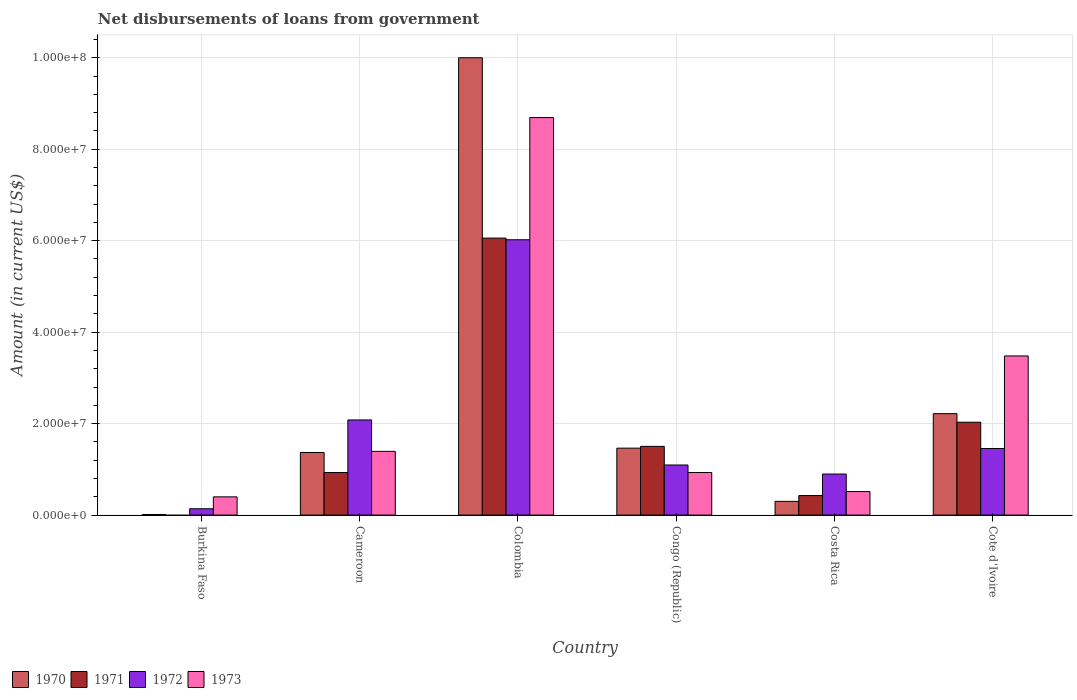How many different coloured bars are there?
Offer a terse response. 4. Are the number of bars per tick equal to the number of legend labels?
Provide a short and direct response. No. How many bars are there on the 6th tick from the right?
Offer a terse response. 3. What is the label of the 3rd group of bars from the left?
Keep it short and to the point. Colombia. What is the amount of loan disbursed from government in 1972 in Colombia?
Give a very brief answer. 6.02e+07. Across all countries, what is the maximum amount of loan disbursed from government in 1971?
Offer a terse response. 6.06e+07. What is the total amount of loan disbursed from government in 1970 in the graph?
Your response must be concise. 1.54e+08. What is the difference between the amount of loan disbursed from government in 1970 in Congo (Republic) and that in Costa Rica?
Offer a very short reply. 1.16e+07. What is the difference between the amount of loan disbursed from government in 1972 in Colombia and the amount of loan disbursed from government in 1970 in Costa Rica?
Offer a terse response. 5.72e+07. What is the average amount of loan disbursed from government in 1971 per country?
Your response must be concise. 1.82e+07. What is the difference between the amount of loan disbursed from government of/in 1972 and amount of loan disbursed from government of/in 1973 in Cameroon?
Give a very brief answer. 6.87e+06. In how many countries, is the amount of loan disbursed from government in 1971 greater than 24000000 US$?
Your response must be concise. 1. What is the ratio of the amount of loan disbursed from government in 1970 in Cameroon to that in Cote d'Ivoire?
Keep it short and to the point. 0.62. Is the amount of loan disbursed from government in 1970 in Cameroon less than that in Colombia?
Give a very brief answer. Yes. Is the difference between the amount of loan disbursed from government in 1972 in Burkina Faso and Colombia greater than the difference between the amount of loan disbursed from government in 1973 in Burkina Faso and Colombia?
Ensure brevity in your answer.  Yes. What is the difference between the highest and the second highest amount of loan disbursed from government in 1970?
Your answer should be very brief. 8.54e+07. What is the difference between the highest and the lowest amount of loan disbursed from government in 1973?
Your answer should be very brief. 8.29e+07. How many bars are there?
Keep it short and to the point. 23. Are all the bars in the graph horizontal?
Your answer should be compact. No. How many countries are there in the graph?
Your answer should be compact. 6. What is the difference between two consecutive major ticks on the Y-axis?
Your answer should be very brief. 2.00e+07. Does the graph contain grids?
Offer a terse response. Yes. How many legend labels are there?
Ensure brevity in your answer.  4. How are the legend labels stacked?
Provide a short and direct response. Horizontal. What is the title of the graph?
Make the answer very short. Net disbursements of loans from government. What is the Amount (in current US$) of 1970 in Burkina Faso?
Provide a succinct answer. 1.29e+05. What is the Amount (in current US$) in 1972 in Burkina Faso?
Provide a succinct answer. 1.38e+06. What is the Amount (in current US$) in 1973 in Burkina Faso?
Provide a succinct answer. 3.98e+06. What is the Amount (in current US$) in 1970 in Cameroon?
Your answer should be very brief. 1.37e+07. What is the Amount (in current US$) in 1971 in Cameroon?
Keep it short and to the point. 9.30e+06. What is the Amount (in current US$) of 1972 in Cameroon?
Provide a short and direct response. 2.08e+07. What is the Amount (in current US$) of 1973 in Cameroon?
Make the answer very short. 1.39e+07. What is the Amount (in current US$) of 1970 in Colombia?
Your answer should be compact. 1.00e+08. What is the Amount (in current US$) of 1971 in Colombia?
Your response must be concise. 6.06e+07. What is the Amount (in current US$) of 1972 in Colombia?
Provide a short and direct response. 6.02e+07. What is the Amount (in current US$) in 1973 in Colombia?
Offer a terse response. 8.69e+07. What is the Amount (in current US$) in 1970 in Congo (Republic)?
Make the answer very short. 1.46e+07. What is the Amount (in current US$) in 1971 in Congo (Republic)?
Give a very brief answer. 1.50e+07. What is the Amount (in current US$) in 1972 in Congo (Republic)?
Offer a terse response. 1.10e+07. What is the Amount (in current US$) in 1973 in Congo (Republic)?
Your answer should be very brief. 9.30e+06. What is the Amount (in current US$) in 1970 in Costa Rica?
Your answer should be compact. 3.00e+06. What is the Amount (in current US$) in 1971 in Costa Rica?
Your response must be concise. 4.27e+06. What is the Amount (in current US$) in 1972 in Costa Rica?
Provide a short and direct response. 8.97e+06. What is the Amount (in current US$) of 1973 in Costa Rica?
Give a very brief answer. 5.14e+06. What is the Amount (in current US$) in 1970 in Cote d'Ivoire?
Make the answer very short. 2.22e+07. What is the Amount (in current US$) of 1971 in Cote d'Ivoire?
Offer a very short reply. 2.03e+07. What is the Amount (in current US$) of 1972 in Cote d'Ivoire?
Provide a succinct answer. 1.45e+07. What is the Amount (in current US$) in 1973 in Cote d'Ivoire?
Your answer should be very brief. 3.48e+07. Across all countries, what is the maximum Amount (in current US$) of 1970?
Your answer should be compact. 1.00e+08. Across all countries, what is the maximum Amount (in current US$) in 1971?
Your answer should be very brief. 6.06e+07. Across all countries, what is the maximum Amount (in current US$) in 1972?
Offer a very short reply. 6.02e+07. Across all countries, what is the maximum Amount (in current US$) of 1973?
Ensure brevity in your answer.  8.69e+07. Across all countries, what is the minimum Amount (in current US$) of 1970?
Make the answer very short. 1.29e+05. Across all countries, what is the minimum Amount (in current US$) of 1972?
Offer a very short reply. 1.38e+06. Across all countries, what is the minimum Amount (in current US$) in 1973?
Ensure brevity in your answer.  3.98e+06. What is the total Amount (in current US$) of 1970 in the graph?
Provide a succinct answer. 1.54e+08. What is the total Amount (in current US$) of 1971 in the graph?
Provide a succinct answer. 1.09e+08. What is the total Amount (in current US$) of 1972 in the graph?
Offer a terse response. 1.17e+08. What is the total Amount (in current US$) in 1973 in the graph?
Your answer should be compact. 1.54e+08. What is the difference between the Amount (in current US$) in 1970 in Burkina Faso and that in Cameroon?
Provide a succinct answer. -1.36e+07. What is the difference between the Amount (in current US$) in 1972 in Burkina Faso and that in Cameroon?
Keep it short and to the point. -1.94e+07. What is the difference between the Amount (in current US$) in 1973 in Burkina Faso and that in Cameroon?
Your response must be concise. -9.94e+06. What is the difference between the Amount (in current US$) of 1970 in Burkina Faso and that in Colombia?
Make the answer very short. -9.99e+07. What is the difference between the Amount (in current US$) in 1972 in Burkina Faso and that in Colombia?
Keep it short and to the point. -5.88e+07. What is the difference between the Amount (in current US$) in 1973 in Burkina Faso and that in Colombia?
Give a very brief answer. -8.29e+07. What is the difference between the Amount (in current US$) of 1970 in Burkina Faso and that in Congo (Republic)?
Provide a short and direct response. -1.45e+07. What is the difference between the Amount (in current US$) of 1972 in Burkina Faso and that in Congo (Republic)?
Your response must be concise. -9.57e+06. What is the difference between the Amount (in current US$) in 1973 in Burkina Faso and that in Congo (Republic)?
Offer a terse response. -5.32e+06. What is the difference between the Amount (in current US$) of 1970 in Burkina Faso and that in Costa Rica?
Make the answer very short. -2.87e+06. What is the difference between the Amount (in current US$) of 1972 in Burkina Faso and that in Costa Rica?
Give a very brief answer. -7.59e+06. What is the difference between the Amount (in current US$) of 1973 in Burkina Faso and that in Costa Rica?
Make the answer very short. -1.15e+06. What is the difference between the Amount (in current US$) in 1970 in Burkina Faso and that in Cote d'Ivoire?
Your answer should be compact. -2.20e+07. What is the difference between the Amount (in current US$) of 1972 in Burkina Faso and that in Cote d'Ivoire?
Your answer should be very brief. -1.32e+07. What is the difference between the Amount (in current US$) of 1973 in Burkina Faso and that in Cote d'Ivoire?
Give a very brief answer. -3.08e+07. What is the difference between the Amount (in current US$) in 1970 in Cameroon and that in Colombia?
Provide a short and direct response. -8.63e+07. What is the difference between the Amount (in current US$) of 1971 in Cameroon and that in Colombia?
Provide a succinct answer. -5.13e+07. What is the difference between the Amount (in current US$) of 1972 in Cameroon and that in Colombia?
Your answer should be very brief. -3.94e+07. What is the difference between the Amount (in current US$) of 1973 in Cameroon and that in Colombia?
Provide a succinct answer. -7.30e+07. What is the difference between the Amount (in current US$) in 1970 in Cameroon and that in Congo (Republic)?
Your response must be concise. -9.51e+05. What is the difference between the Amount (in current US$) of 1971 in Cameroon and that in Congo (Republic)?
Give a very brief answer. -5.72e+06. What is the difference between the Amount (in current US$) in 1972 in Cameroon and that in Congo (Republic)?
Keep it short and to the point. 9.85e+06. What is the difference between the Amount (in current US$) in 1973 in Cameroon and that in Congo (Republic)?
Ensure brevity in your answer.  4.63e+06. What is the difference between the Amount (in current US$) of 1970 in Cameroon and that in Costa Rica?
Offer a very short reply. 1.07e+07. What is the difference between the Amount (in current US$) in 1971 in Cameroon and that in Costa Rica?
Make the answer very short. 5.03e+06. What is the difference between the Amount (in current US$) of 1972 in Cameroon and that in Costa Rica?
Provide a short and direct response. 1.18e+07. What is the difference between the Amount (in current US$) in 1973 in Cameroon and that in Costa Rica?
Your answer should be very brief. 8.79e+06. What is the difference between the Amount (in current US$) of 1970 in Cameroon and that in Cote d'Ivoire?
Your response must be concise. -8.50e+06. What is the difference between the Amount (in current US$) of 1971 in Cameroon and that in Cote d'Ivoire?
Provide a short and direct response. -1.10e+07. What is the difference between the Amount (in current US$) in 1972 in Cameroon and that in Cote d'Ivoire?
Offer a terse response. 6.25e+06. What is the difference between the Amount (in current US$) of 1973 in Cameroon and that in Cote d'Ivoire?
Keep it short and to the point. -2.09e+07. What is the difference between the Amount (in current US$) in 1970 in Colombia and that in Congo (Republic)?
Ensure brevity in your answer.  8.54e+07. What is the difference between the Amount (in current US$) of 1971 in Colombia and that in Congo (Republic)?
Give a very brief answer. 4.55e+07. What is the difference between the Amount (in current US$) in 1972 in Colombia and that in Congo (Republic)?
Your response must be concise. 4.92e+07. What is the difference between the Amount (in current US$) of 1973 in Colombia and that in Congo (Republic)?
Provide a short and direct response. 7.76e+07. What is the difference between the Amount (in current US$) in 1970 in Colombia and that in Costa Rica?
Ensure brevity in your answer.  9.70e+07. What is the difference between the Amount (in current US$) in 1971 in Colombia and that in Costa Rica?
Your answer should be compact. 5.63e+07. What is the difference between the Amount (in current US$) in 1972 in Colombia and that in Costa Rica?
Ensure brevity in your answer.  5.12e+07. What is the difference between the Amount (in current US$) of 1973 in Colombia and that in Costa Rica?
Your response must be concise. 8.18e+07. What is the difference between the Amount (in current US$) in 1970 in Colombia and that in Cote d'Ivoire?
Make the answer very short. 7.78e+07. What is the difference between the Amount (in current US$) in 1971 in Colombia and that in Cote d'Ivoire?
Provide a succinct answer. 4.03e+07. What is the difference between the Amount (in current US$) in 1972 in Colombia and that in Cote d'Ivoire?
Give a very brief answer. 4.56e+07. What is the difference between the Amount (in current US$) in 1973 in Colombia and that in Cote d'Ivoire?
Your response must be concise. 5.21e+07. What is the difference between the Amount (in current US$) of 1970 in Congo (Republic) and that in Costa Rica?
Provide a succinct answer. 1.16e+07. What is the difference between the Amount (in current US$) of 1971 in Congo (Republic) and that in Costa Rica?
Offer a terse response. 1.08e+07. What is the difference between the Amount (in current US$) of 1972 in Congo (Republic) and that in Costa Rica?
Offer a terse response. 1.98e+06. What is the difference between the Amount (in current US$) in 1973 in Congo (Republic) and that in Costa Rica?
Your answer should be compact. 4.16e+06. What is the difference between the Amount (in current US$) in 1970 in Congo (Republic) and that in Cote d'Ivoire?
Your response must be concise. -7.54e+06. What is the difference between the Amount (in current US$) in 1971 in Congo (Republic) and that in Cote d'Ivoire?
Give a very brief answer. -5.28e+06. What is the difference between the Amount (in current US$) of 1972 in Congo (Republic) and that in Cote d'Ivoire?
Offer a very short reply. -3.60e+06. What is the difference between the Amount (in current US$) of 1973 in Congo (Republic) and that in Cote d'Ivoire?
Provide a short and direct response. -2.55e+07. What is the difference between the Amount (in current US$) in 1970 in Costa Rica and that in Cote d'Ivoire?
Give a very brief answer. -1.92e+07. What is the difference between the Amount (in current US$) in 1971 in Costa Rica and that in Cote d'Ivoire?
Your answer should be compact. -1.60e+07. What is the difference between the Amount (in current US$) in 1972 in Costa Rica and that in Cote d'Ivoire?
Your answer should be compact. -5.58e+06. What is the difference between the Amount (in current US$) of 1973 in Costa Rica and that in Cote d'Ivoire?
Ensure brevity in your answer.  -2.97e+07. What is the difference between the Amount (in current US$) in 1970 in Burkina Faso and the Amount (in current US$) in 1971 in Cameroon?
Your answer should be compact. -9.17e+06. What is the difference between the Amount (in current US$) in 1970 in Burkina Faso and the Amount (in current US$) in 1972 in Cameroon?
Keep it short and to the point. -2.07e+07. What is the difference between the Amount (in current US$) of 1970 in Burkina Faso and the Amount (in current US$) of 1973 in Cameroon?
Keep it short and to the point. -1.38e+07. What is the difference between the Amount (in current US$) in 1972 in Burkina Faso and the Amount (in current US$) in 1973 in Cameroon?
Provide a succinct answer. -1.25e+07. What is the difference between the Amount (in current US$) in 1970 in Burkina Faso and the Amount (in current US$) in 1971 in Colombia?
Offer a very short reply. -6.04e+07. What is the difference between the Amount (in current US$) in 1970 in Burkina Faso and the Amount (in current US$) in 1972 in Colombia?
Provide a short and direct response. -6.01e+07. What is the difference between the Amount (in current US$) of 1970 in Burkina Faso and the Amount (in current US$) of 1973 in Colombia?
Give a very brief answer. -8.68e+07. What is the difference between the Amount (in current US$) in 1972 in Burkina Faso and the Amount (in current US$) in 1973 in Colombia?
Your answer should be compact. -8.55e+07. What is the difference between the Amount (in current US$) in 1970 in Burkina Faso and the Amount (in current US$) in 1971 in Congo (Republic)?
Make the answer very short. -1.49e+07. What is the difference between the Amount (in current US$) of 1970 in Burkina Faso and the Amount (in current US$) of 1972 in Congo (Republic)?
Provide a short and direct response. -1.08e+07. What is the difference between the Amount (in current US$) in 1970 in Burkina Faso and the Amount (in current US$) in 1973 in Congo (Republic)?
Make the answer very short. -9.17e+06. What is the difference between the Amount (in current US$) in 1972 in Burkina Faso and the Amount (in current US$) in 1973 in Congo (Republic)?
Offer a very short reply. -7.92e+06. What is the difference between the Amount (in current US$) of 1970 in Burkina Faso and the Amount (in current US$) of 1971 in Costa Rica?
Provide a succinct answer. -4.14e+06. What is the difference between the Amount (in current US$) in 1970 in Burkina Faso and the Amount (in current US$) in 1972 in Costa Rica?
Provide a short and direct response. -8.84e+06. What is the difference between the Amount (in current US$) of 1970 in Burkina Faso and the Amount (in current US$) of 1973 in Costa Rica?
Offer a very short reply. -5.01e+06. What is the difference between the Amount (in current US$) in 1972 in Burkina Faso and the Amount (in current US$) in 1973 in Costa Rica?
Offer a terse response. -3.76e+06. What is the difference between the Amount (in current US$) in 1970 in Burkina Faso and the Amount (in current US$) in 1971 in Cote d'Ivoire?
Offer a terse response. -2.02e+07. What is the difference between the Amount (in current US$) of 1970 in Burkina Faso and the Amount (in current US$) of 1972 in Cote d'Ivoire?
Give a very brief answer. -1.44e+07. What is the difference between the Amount (in current US$) of 1970 in Burkina Faso and the Amount (in current US$) of 1973 in Cote d'Ivoire?
Provide a succinct answer. -3.47e+07. What is the difference between the Amount (in current US$) in 1972 in Burkina Faso and the Amount (in current US$) in 1973 in Cote d'Ivoire?
Provide a succinct answer. -3.34e+07. What is the difference between the Amount (in current US$) of 1970 in Cameroon and the Amount (in current US$) of 1971 in Colombia?
Offer a very short reply. -4.69e+07. What is the difference between the Amount (in current US$) of 1970 in Cameroon and the Amount (in current US$) of 1972 in Colombia?
Make the answer very short. -4.65e+07. What is the difference between the Amount (in current US$) in 1970 in Cameroon and the Amount (in current US$) in 1973 in Colombia?
Your answer should be very brief. -7.32e+07. What is the difference between the Amount (in current US$) in 1971 in Cameroon and the Amount (in current US$) in 1972 in Colombia?
Your answer should be compact. -5.09e+07. What is the difference between the Amount (in current US$) in 1971 in Cameroon and the Amount (in current US$) in 1973 in Colombia?
Your answer should be very brief. -7.76e+07. What is the difference between the Amount (in current US$) in 1972 in Cameroon and the Amount (in current US$) in 1973 in Colombia?
Ensure brevity in your answer.  -6.61e+07. What is the difference between the Amount (in current US$) of 1970 in Cameroon and the Amount (in current US$) of 1971 in Congo (Republic)?
Ensure brevity in your answer.  -1.34e+06. What is the difference between the Amount (in current US$) of 1970 in Cameroon and the Amount (in current US$) of 1972 in Congo (Republic)?
Provide a succinct answer. 2.73e+06. What is the difference between the Amount (in current US$) in 1970 in Cameroon and the Amount (in current US$) in 1973 in Congo (Republic)?
Make the answer very short. 4.38e+06. What is the difference between the Amount (in current US$) of 1971 in Cameroon and the Amount (in current US$) of 1972 in Congo (Republic)?
Offer a terse response. -1.65e+06. What is the difference between the Amount (in current US$) in 1971 in Cameroon and the Amount (in current US$) in 1973 in Congo (Republic)?
Your response must be concise. 0. What is the difference between the Amount (in current US$) in 1972 in Cameroon and the Amount (in current US$) in 1973 in Congo (Republic)?
Offer a very short reply. 1.15e+07. What is the difference between the Amount (in current US$) of 1970 in Cameroon and the Amount (in current US$) of 1971 in Costa Rica?
Your response must be concise. 9.41e+06. What is the difference between the Amount (in current US$) of 1970 in Cameroon and the Amount (in current US$) of 1972 in Costa Rica?
Offer a very short reply. 4.71e+06. What is the difference between the Amount (in current US$) of 1970 in Cameroon and the Amount (in current US$) of 1973 in Costa Rica?
Provide a succinct answer. 8.55e+06. What is the difference between the Amount (in current US$) in 1971 in Cameroon and the Amount (in current US$) in 1972 in Costa Rica?
Offer a very short reply. 3.30e+05. What is the difference between the Amount (in current US$) of 1971 in Cameroon and the Amount (in current US$) of 1973 in Costa Rica?
Your response must be concise. 4.16e+06. What is the difference between the Amount (in current US$) in 1972 in Cameroon and the Amount (in current US$) in 1973 in Costa Rica?
Your answer should be compact. 1.57e+07. What is the difference between the Amount (in current US$) of 1970 in Cameroon and the Amount (in current US$) of 1971 in Cote d'Ivoire?
Provide a short and direct response. -6.62e+06. What is the difference between the Amount (in current US$) of 1970 in Cameroon and the Amount (in current US$) of 1972 in Cote d'Ivoire?
Provide a short and direct response. -8.66e+05. What is the difference between the Amount (in current US$) in 1970 in Cameroon and the Amount (in current US$) in 1973 in Cote d'Ivoire?
Offer a terse response. -2.11e+07. What is the difference between the Amount (in current US$) of 1971 in Cameroon and the Amount (in current US$) of 1972 in Cote d'Ivoire?
Ensure brevity in your answer.  -5.25e+06. What is the difference between the Amount (in current US$) of 1971 in Cameroon and the Amount (in current US$) of 1973 in Cote d'Ivoire?
Offer a terse response. -2.55e+07. What is the difference between the Amount (in current US$) in 1972 in Cameroon and the Amount (in current US$) in 1973 in Cote d'Ivoire?
Make the answer very short. -1.40e+07. What is the difference between the Amount (in current US$) of 1970 in Colombia and the Amount (in current US$) of 1971 in Congo (Republic)?
Provide a short and direct response. 8.50e+07. What is the difference between the Amount (in current US$) of 1970 in Colombia and the Amount (in current US$) of 1972 in Congo (Republic)?
Ensure brevity in your answer.  8.90e+07. What is the difference between the Amount (in current US$) in 1970 in Colombia and the Amount (in current US$) in 1973 in Congo (Republic)?
Your answer should be very brief. 9.07e+07. What is the difference between the Amount (in current US$) of 1971 in Colombia and the Amount (in current US$) of 1972 in Congo (Republic)?
Give a very brief answer. 4.96e+07. What is the difference between the Amount (in current US$) in 1971 in Colombia and the Amount (in current US$) in 1973 in Congo (Republic)?
Your response must be concise. 5.13e+07. What is the difference between the Amount (in current US$) of 1972 in Colombia and the Amount (in current US$) of 1973 in Congo (Republic)?
Keep it short and to the point. 5.09e+07. What is the difference between the Amount (in current US$) in 1970 in Colombia and the Amount (in current US$) in 1971 in Costa Rica?
Offer a terse response. 9.57e+07. What is the difference between the Amount (in current US$) of 1970 in Colombia and the Amount (in current US$) of 1972 in Costa Rica?
Make the answer very short. 9.10e+07. What is the difference between the Amount (in current US$) of 1970 in Colombia and the Amount (in current US$) of 1973 in Costa Rica?
Give a very brief answer. 9.49e+07. What is the difference between the Amount (in current US$) of 1971 in Colombia and the Amount (in current US$) of 1972 in Costa Rica?
Your answer should be very brief. 5.16e+07. What is the difference between the Amount (in current US$) of 1971 in Colombia and the Amount (in current US$) of 1973 in Costa Rica?
Ensure brevity in your answer.  5.54e+07. What is the difference between the Amount (in current US$) of 1972 in Colombia and the Amount (in current US$) of 1973 in Costa Rica?
Offer a terse response. 5.51e+07. What is the difference between the Amount (in current US$) of 1970 in Colombia and the Amount (in current US$) of 1971 in Cote d'Ivoire?
Offer a very short reply. 7.97e+07. What is the difference between the Amount (in current US$) in 1970 in Colombia and the Amount (in current US$) in 1972 in Cote d'Ivoire?
Your answer should be very brief. 8.54e+07. What is the difference between the Amount (in current US$) in 1970 in Colombia and the Amount (in current US$) in 1973 in Cote d'Ivoire?
Offer a terse response. 6.52e+07. What is the difference between the Amount (in current US$) of 1971 in Colombia and the Amount (in current US$) of 1972 in Cote d'Ivoire?
Ensure brevity in your answer.  4.60e+07. What is the difference between the Amount (in current US$) in 1971 in Colombia and the Amount (in current US$) in 1973 in Cote d'Ivoire?
Offer a terse response. 2.58e+07. What is the difference between the Amount (in current US$) in 1972 in Colombia and the Amount (in current US$) in 1973 in Cote d'Ivoire?
Provide a short and direct response. 2.54e+07. What is the difference between the Amount (in current US$) in 1970 in Congo (Republic) and the Amount (in current US$) in 1971 in Costa Rica?
Give a very brief answer. 1.04e+07. What is the difference between the Amount (in current US$) in 1970 in Congo (Republic) and the Amount (in current US$) in 1972 in Costa Rica?
Offer a very short reply. 5.66e+06. What is the difference between the Amount (in current US$) of 1970 in Congo (Republic) and the Amount (in current US$) of 1973 in Costa Rica?
Offer a very short reply. 9.50e+06. What is the difference between the Amount (in current US$) of 1971 in Congo (Republic) and the Amount (in current US$) of 1972 in Costa Rica?
Keep it short and to the point. 6.05e+06. What is the difference between the Amount (in current US$) in 1971 in Congo (Republic) and the Amount (in current US$) in 1973 in Costa Rica?
Offer a terse response. 9.88e+06. What is the difference between the Amount (in current US$) in 1972 in Congo (Republic) and the Amount (in current US$) in 1973 in Costa Rica?
Provide a succinct answer. 5.81e+06. What is the difference between the Amount (in current US$) of 1970 in Congo (Republic) and the Amount (in current US$) of 1971 in Cote d'Ivoire?
Make the answer very short. -5.67e+06. What is the difference between the Amount (in current US$) in 1970 in Congo (Republic) and the Amount (in current US$) in 1972 in Cote d'Ivoire?
Provide a succinct answer. 8.50e+04. What is the difference between the Amount (in current US$) in 1970 in Congo (Republic) and the Amount (in current US$) in 1973 in Cote d'Ivoire?
Offer a very short reply. -2.02e+07. What is the difference between the Amount (in current US$) in 1971 in Congo (Republic) and the Amount (in current US$) in 1972 in Cote d'Ivoire?
Keep it short and to the point. 4.73e+05. What is the difference between the Amount (in current US$) of 1971 in Congo (Republic) and the Amount (in current US$) of 1973 in Cote d'Ivoire?
Your response must be concise. -1.98e+07. What is the difference between the Amount (in current US$) in 1972 in Congo (Republic) and the Amount (in current US$) in 1973 in Cote d'Ivoire?
Give a very brief answer. -2.38e+07. What is the difference between the Amount (in current US$) in 1970 in Costa Rica and the Amount (in current US$) in 1971 in Cote d'Ivoire?
Provide a short and direct response. -1.73e+07. What is the difference between the Amount (in current US$) of 1970 in Costa Rica and the Amount (in current US$) of 1972 in Cote d'Ivoire?
Keep it short and to the point. -1.16e+07. What is the difference between the Amount (in current US$) of 1970 in Costa Rica and the Amount (in current US$) of 1973 in Cote d'Ivoire?
Keep it short and to the point. -3.18e+07. What is the difference between the Amount (in current US$) in 1971 in Costa Rica and the Amount (in current US$) in 1972 in Cote d'Ivoire?
Offer a very short reply. -1.03e+07. What is the difference between the Amount (in current US$) of 1971 in Costa Rica and the Amount (in current US$) of 1973 in Cote d'Ivoire?
Your response must be concise. -3.05e+07. What is the difference between the Amount (in current US$) in 1972 in Costa Rica and the Amount (in current US$) in 1973 in Cote d'Ivoire?
Ensure brevity in your answer.  -2.58e+07. What is the average Amount (in current US$) in 1970 per country?
Keep it short and to the point. 2.56e+07. What is the average Amount (in current US$) in 1971 per country?
Offer a terse response. 1.82e+07. What is the average Amount (in current US$) in 1972 per country?
Make the answer very short. 1.95e+07. What is the average Amount (in current US$) in 1973 per country?
Give a very brief answer. 2.57e+07. What is the difference between the Amount (in current US$) of 1970 and Amount (in current US$) of 1972 in Burkina Faso?
Provide a short and direct response. -1.25e+06. What is the difference between the Amount (in current US$) of 1970 and Amount (in current US$) of 1973 in Burkina Faso?
Keep it short and to the point. -3.86e+06. What is the difference between the Amount (in current US$) in 1972 and Amount (in current US$) in 1973 in Burkina Faso?
Make the answer very short. -2.60e+06. What is the difference between the Amount (in current US$) in 1970 and Amount (in current US$) in 1971 in Cameroon?
Give a very brief answer. 4.38e+06. What is the difference between the Amount (in current US$) of 1970 and Amount (in current US$) of 1972 in Cameroon?
Keep it short and to the point. -7.12e+06. What is the difference between the Amount (in current US$) of 1970 and Amount (in current US$) of 1973 in Cameroon?
Your answer should be compact. -2.45e+05. What is the difference between the Amount (in current US$) in 1971 and Amount (in current US$) in 1972 in Cameroon?
Ensure brevity in your answer.  -1.15e+07. What is the difference between the Amount (in current US$) in 1971 and Amount (in current US$) in 1973 in Cameroon?
Offer a terse response. -4.63e+06. What is the difference between the Amount (in current US$) of 1972 and Amount (in current US$) of 1973 in Cameroon?
Give a very brief answer. 6.87e+06. What is the difference between the Amount (in current US$) of 1970 and Amount (in current US$) of 1971 in Colombia?
Offer a terse response. 3.94e+07. What is the difference between the Amount (in current US$) of 1970 and Amount (in current US$) of 1972 in Colombia?
Provide a succinct answer. 3.98e+07. What is the difference between the Amount (in current US$) of 1970 and Amount (in current US$) of 1973 in Colombia?
Make the answer very short. 1.31e+07. What is the difference between the Amount (in current US$) in 1971 and Amount (in current US$) in 1972 in Colombia?
Offer a very short reply. 3.62e+05. What is the difference between the Amount (in current US$) in 1971 and Amount (in current US$) in 1973 in Colombia?
Your answer should be very brief. -2.64e+07. What is the difference between the Amount (in current US$) in 1972 and Amount (in current US$) in 1973 in Colombia?
Ensure brevity in your answer.  -2.67e+07. What is the difference between the Amount (in current US$) in 1970 and Amount (in current US$) in 1971 in Congo (Republic)?
Your response must be concise. -3.88e+05. What is the difference between the Amount (in current US$) in 1970 and Amount (in current US$) in 1972 in Congo (Republic)?
Your answer should be very brief. 3.68e+06. What is the difference between the Amount (in current US$) in 1970 and Amount (in current US$) in 1973 in Congo (Republic)?
Offer a terse response. 5.33e+06. What is the difference between the Amount (in current US$) of 1971 and Amount (in current US$) of 1972 in Congo (Republic)?
Your answer should be compact. 4.07e+06. What is the difference between the Amount (in current US$) in 1971 and Amount (in current US$) in 1973 in Congo (Republic)?
Provide a short and direct response. 5.72e+06. What is the difference between the Amount (in current US$) in 1972 and Amount (in current US$) in 1973 in Congo (Republic)?
Your response must be concise. 1.65e+06. What is the difference between the Amount (in current US$) of 1970 and Amount (in current US$) of 1971 in Costa Rica?
Provide a short and direct response. -1.27e+06. What is the difference between the Amount (in current US$) in 1970 and Amount (in current US$) in 1972 in Costa Rica?
Provide a succinct answer. -5.98e+06. What is the difference between the Amount (in current US$) in 1970 and Amount (in current US$) in 1973 in Costa Rica?
Offer a very short reply. -2.14e+06. What is the difference between the Amount (in current US$) in 1971 and Amount (in current US$) in 1972 in Costa Rica?
Offer a very short reply. -4.70e+06. What is the difference between the Amount (in current US$) in 1971 and Amount (in current US$) in 1973 in Costa Rica?
Your answer should be very brief. -8.68e+05. What is the difference between the Amount (in current US$) in 1972 and Amount (in current US$) in 1973 in Costa Rica?
Your answer should be compact. 3.84e+06. What is the difference between the Amount (in current US$) of 1970 and Amount (in current US$) of 1971 in Cote d'Ivoire?
Provide a short and direct response. 1.88e+06. What is the difference between the Amount (in current US$) of 1970 and Amount (in current US$) of 1972 in Cote d'Ivoire?
Provide a succinct answer. 7.63e+06. What is the difference between the Amount (in current US$) in 1970 and Amount (in current US$) in 1973 in Cote d'Ivoire?
Offer a terse response. -1.26e+07. What is the difference between the Amount (in current US$) of 1971 and Amount (in current US$) of 1972 in Cote d'Ivoire?
Make the answer very short. 5.75e+06. What is the difference between the Amount (in current US$) in 1971 and Amount (in current US$) in 1973 in Cote d'Ivoire?
Provide a short and direct response. -1.45e+07. What is the difference between the Amount (in current US$) in 1972 and Amount (in current US$) in 1973 in Cote d'Ivoire?
Provide a short and direct response. -2.02e+07. What is the ratio of the Amount (in current US$) of 1970 in Burkina Faso to that in Cameroon?
Provide a short and direct response. 0.01. What is the ratio of the Amount (in current US$) in 1972 in Burkina Faso to that in Cameroon?
Give a very brief answer. 0.07. What is the ratio of the Amount (in current US$) of 1973 in Burkina Faso to that in Cameroon?
Provide a succinct answer. 0.29. What is the ratio of the Amount (in current US$) in 1970 in Burkina Faso to that in Colombia?
Make the answer very short. 0. What is the ratio of the Amount (in current US$) in 1972 in Burkina Faso to that in Colombia?
Your response must be concise. 0.02. What is the ratio of the Amount (in current US$) of 1973 in Burkina Faso to that in Colombia?
Make the answer very short. 0.05. What is the ratio of the Amount (in current US$) in 1970 in Burkina Faso to that in Congo (Republic)?
Keep it short and to the point. 0.01. What is the ratio of the Amount (in current US$) in 1972 in Burkina Faso to that in Congo (Republic)?
Ensure brevity in your answer.  0.13. What is the ratio of the Amount (in current US$) of 1973 in Burkina Faso to that in Congo (Republic)?
Offer a very short reply. 0.43. What is the ratio of the Amount (in current US$) of 1970 in Burkina Faso to that in Costa Rica?
Provide a succinct answer. 0.04. What is the ratio of the Amount (in current US$) in 1972 in Burkina Faso to that in Costa Rica?
Offer a terse response. 0.15. What is the ratio of the Amount (in current US$) in 1973 in Burkina Faso to that in Costa Rica?
Your response must be concise. 0.78. What is the ratio of the Amount (in current US$) of 1970 in Burkina Faso to that in Cote d'Ivoire?
Offer a very short reply. 0.01. What is the ratio of the Amount (in current US$) of 1972 in Burkina Faso to that in Cote d'Ivoire?
Offer a very short reply. 0.09. What is the ratio of the Amount (in current US$) of 1973 in Burkina Faso to that in Cote d'Ivoire?
Your answer should be compact. 0.11. What is the ratio of the Amount (in current US$) of 1970 in Cameroon to that in Colombia?
Provide a succinct answer. 0.14. What is the ratio of the Amount (in current US$) of 1971 in Cameroon to that in Colombia?
Your response must be concise. 0.15. What is the ratio of the Amount (in current US$) in 1972 in Cameroon to that in Colombia?
Your answer should be very brief. 0.35. What is the ratio of the Amount (in current US$) in 1973 in Cameroon to that in Colombia?
Keep it short and to the point. 0.16. What is the ratio of the Amount (in current US$) of 1970 in Cameroon to that in Congo (Republic)?
Offer a very short reply. 0.94. What is the ratio of the Amount (in current US$) of 1971 in Cameroon to that in Congo (Republic)?
Give a very brief answer. 0.62. What is the ratio of the Amount (in current US$) in 1972 in Cameroon to that in Congo (Republic)?
Your answer should be compact. 1.9. What is the ratio of the Amount (in current US$) in 1973 in Cameroon to that in Congo (Republic)?
Ensure brevity in your answer.  1.5. What is the ratio of the Amount (in current US$) in 1970 in Cameroon to that in Costa Rica?
Your response must be concise. 4.57. What is the ratio of the Amount (in current US$) of 1971 in Cameroon to that in Costa Rica?
Ensure brevity in your answer.  2.18. What is the ratio of the Amount (in current US$) of 1972 in Cameroon to that in Costa Rica?
Your answer should be very brief. 2.32. What is the ratio of the Amount (in current US$) of 1973 in Cameroon to that in Costa Rica?
Your answer should be very brief. 2.71. What is the ratio of the Amount (in current US$) of 1970 in Cameroon to that in Cote d'Ivoire?
Keep it short and to the point. 0.62. What is the ratio of the Amount (in current US$) in 1971 in Cameroon to that in Cote d'Ivoire?
Ensure brevity in your answer.  0.46. What is the ratio of the Amount (in current US$) of 1972 in Cameroon to that in Cote d'Ivoire?
Your answer should be very brief. 1.43. What is the ratio of the Amount (in current US$) in 1973 in Cameroon to that in Cote d'Ivoire?
Your answer should be very brief. 0.4. What is the ratio of the Amount (in current US$) in 1970 in Colombia to that in Congo (Republic)?
Give a very brief answer. 6.83. What is the ratio of the Amount (in current US$) in 1971 in Colombia to that in Congo (Republic)?
Ensure brevity in your answer.  4.03. What is the ratio of the Amount (in current US$) in 1972 in Colombia to that in Congo (Republic)?
Your answer should be compact. 5.5. What is the ratio of the Amount (in current US$) in 1973 in Colombia to that in Congo (Republic)?
Your answer should be very brief. 9.34. What is the ratio of the Amount (in current US$) in 1970 in Colombia to that in Costa Rica?
Your answer should be compact. 33.38. What is the ratio of the Amount (in current US$) in 1971 in Colombia to that in Costa Rica?
Your answer should be compact. 14.19. What is the ratio of the Amount (in current US$) in 1972 in Colombia to that in Costa Rica?
Give a very brief answer. 6.71. What is the ratio of the Amount (in current US$) in 1973 in Colombia to that in Costa Rica?
Provide a succinct answer. 16.92. What is the ratio of the Amount (in current US$) in 1970 in Colombia to that in Cote d'Ivoire?
Your answer should be compact. 4.51. What is the ratio of the Amount (in current US$) in 1971 in Colombia to that in Cote d'Ivoire?
Provide a short and direct response. 2.98. What is the ratio of the Amount (in current US$) of 1972 in Colombia to that in Cote d'Ivoire?
Your response must be concise. 4.14. What is the ratio of the Amount (in current US$) in 1973 in Colombia to that in Cote d'Ivoire?
Offer a very short reply. 2.5. What is the ratio of the Amount (in current US$) in 1970 in Congo (Republic) to that in Costa Rica?
Your answer should be compact. 4.88. What is the ratio of the Amount (in current US$) in 1971 in Congo (Republic) to that in Costa Rica?
Offer a terse response. 3.52. What is the ratio of the Amount (in current US$) in 1972 in Congo (Republic) to that in Costa Rica?
Your answer should be compact. 1.22. What is the ratio of the Amount (in current US$) of 1973 in Congo (Republic) to that in Costa Rica?
Your response must be concise. 1.81. What is the ratio of the Amount (in current US$) of 1970 in Congo (Republic) to that in Cote d'Ivoire?
Ensure brevity in your answer.  0.66. What is the ratio of the Amount (in current US$) of 1971 in Congo (Republic) to that in Cote d'Ivoire?
Your response must be concise. 0.74. What is the ratio of the Amount (in current US$) in 1972 in Congo (Republic) to that in Cote d'Ivoire?
Offer a terse response. 0.75. What is the ratio of the Amount (in current US$) in 1973 in Congo (Republic) to that in Cote d'Ivoire?
Offer a very short reply. 0.27. What is the ratio of the Amount (in current US$) of 1970 in Costa Rica to that in Cote d'Ivoire?
Your answer should be very brief. 0.14. What is the ratio of the Amount (in current US$) of 1971 in Costa Rica to that in Cote d'Ivoire?
Make the answer very short. 0.21. What is the ratio of the Amount (in current US$) in 1972 in Costa Rica to that in Cote d'Ivoire?
Provide a succinct answer. 0.62. What is the ratio of the Amount (in current US$) in 1973 in Costa Rica to that in Cote d'Ivoire?
Your answer should be compact. 0.15. What is the difference between the highest and the second highest Amount (in current US$) of 1970?
Give a very brief answer. 7.78e+07. What is the difference between the highest and the second highest Amount (in current US$) in 1971?
Your answer should be very brief. 4.03e+07. What is the difference between the highest and the second highest Amount (in current US$) of 1972?
Give a very brief answer. 3.94e+07. What is the difference between the highest and the second highest Amount (in current US$) of 1973?
Your response must be concise. 5.21e+07. What is the difference between the highest and the lowest Amount (in current US$) of 1970?
Your answer should be compact. 9.99e+07. What is the difference between the highest and the lowest Amount (in current US$) in 1971?
Your answer should be very brief. 6.06e+07. What is the difference between the highest and the lowest Amount (in current US$) in 1972?
Keep it short and to the point. 5.88e+07. What is the difference between the highest and the lowest Amount (in current US$) of 1973?
Your answer should be compact. 8.29e+07. 